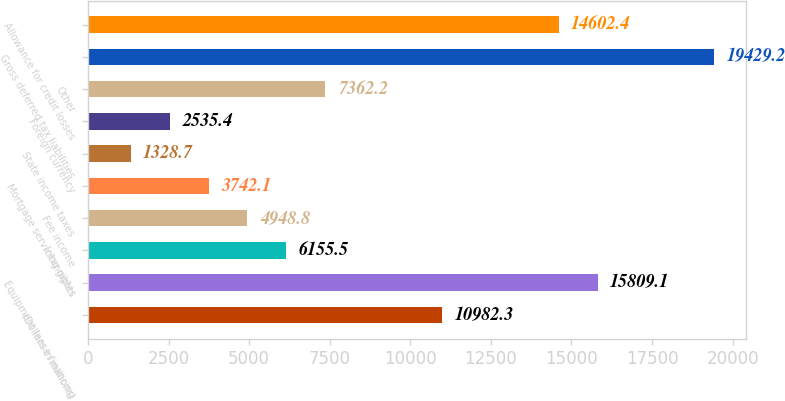Convert chart to OTSL. <chart><loc_0><loc_0><loc_500><loc_500><bar_chart><fcel>(Dollars in millions)<fcel>Equipment lease financing<fcel>Intangibles<fcel>Fee income<fcel>Mortgage servicing rights<fcel>State income taxes<fcel>Foreign currency<fcel>Other<fcel>Gross deferred tax liabilities<fcel>Allowance for credit losses<nl><fcel>10982.3<fcel>15809.1<fcel>6155.5<fcel>4948.8<fcel>3742.1<fcel>1328.7<fcel>2535.4<fcel>7362.2<fcel>19429.2<fcel>14602.4<nl></chart> 